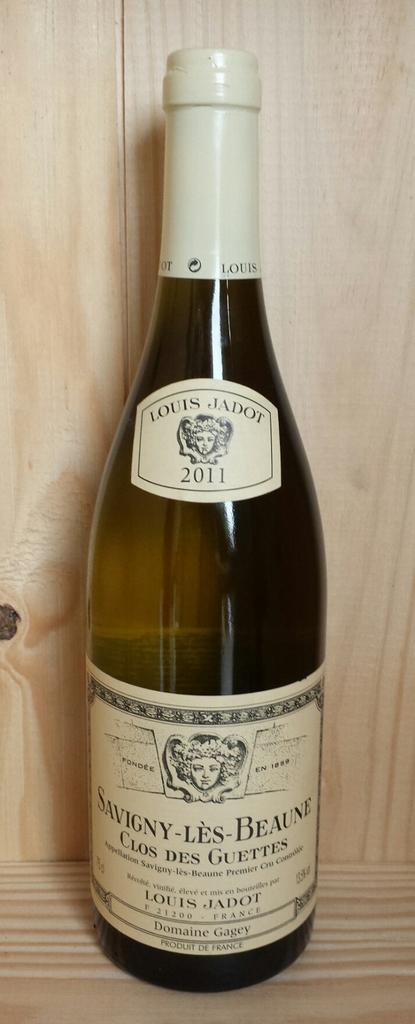What is the year of the beverage?
Provide a succinct answer. 2011. Who made this wine?
Offer a very short reply. Louis jadot. 